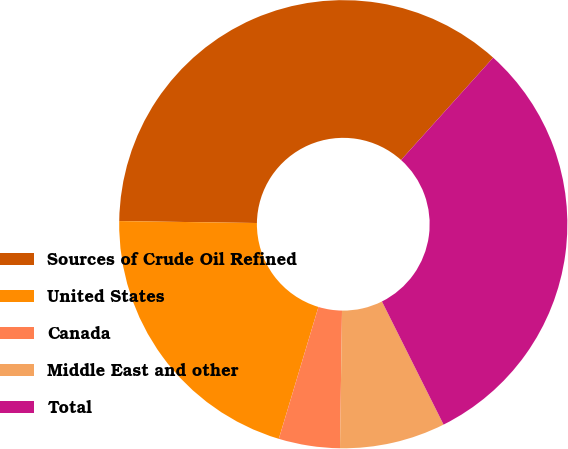<chart> <loc_0><loc_0><loc_500><loc_500><pie_chart><fcel>Sources of Crude Oil Refined<fcel>United States<fcel>Canada<fcel>Middle East and other<fcel>Total<nl><fcel>36.44%<fcel>20.58%<fcel>4.41%<fcel>7.62%<fcel>30.95%<nl></chart> 